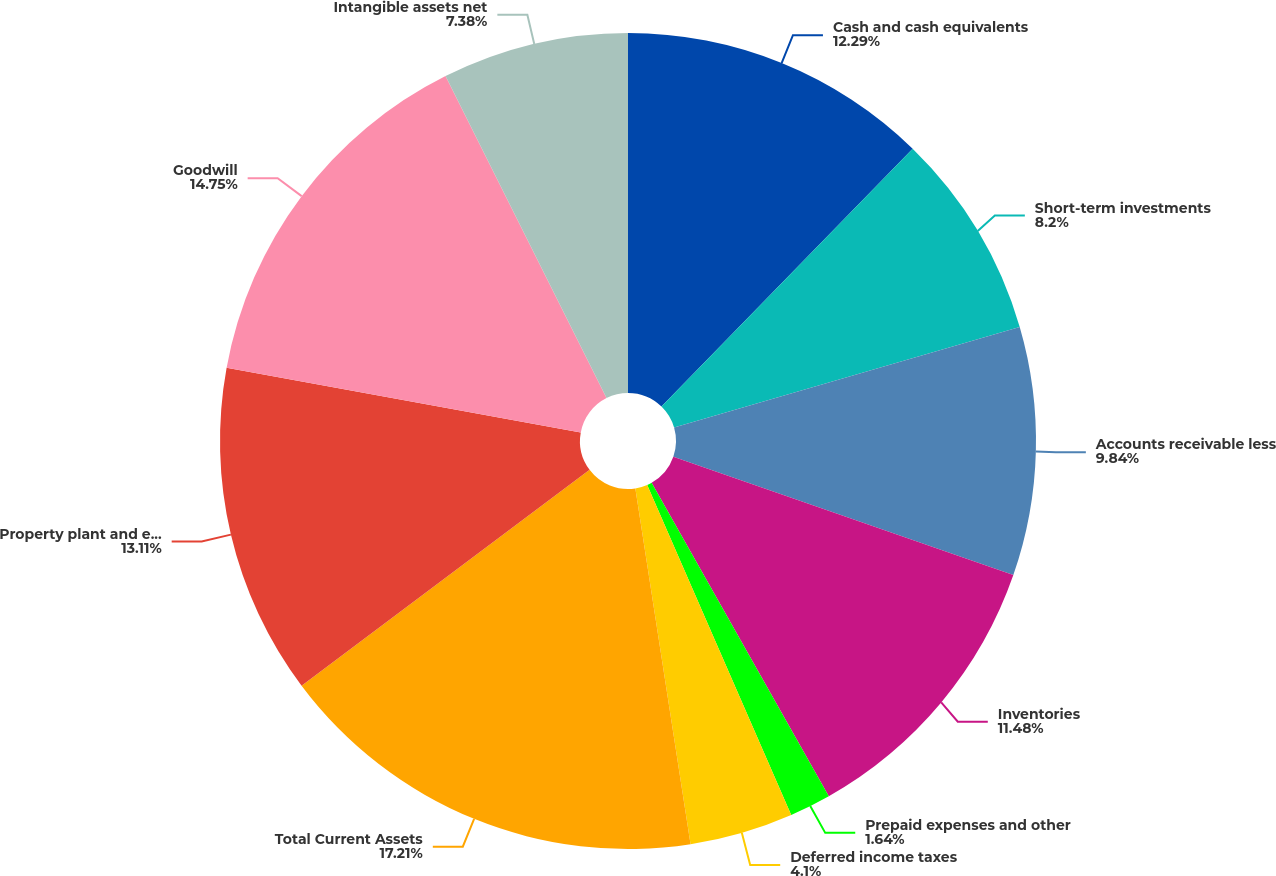Convert chart. <chart><loc_0><loc_0><loc_500><loc_500><pie_chart><fcel>Cash and cash equivalents<fcel>Short-term investments<fcel>Accounts receivable less<fcel>Inventories<fcel>Prepaid expenses and other<fcel>Deferred income taxes<fcel>Total Current Assets<fcel>Property plant and equipment<fcel>Goodwill<fcel>Intangible assets net<nl><fcel>12.29%<fcel>8.2%<fcel>9.84%<fcel>11.48%<fcel>1.64%<fcel>4.1%<fcel>17.21%<fcel>13.11%<fcel>14.75%<fcel>7.38%<nl></chart> 